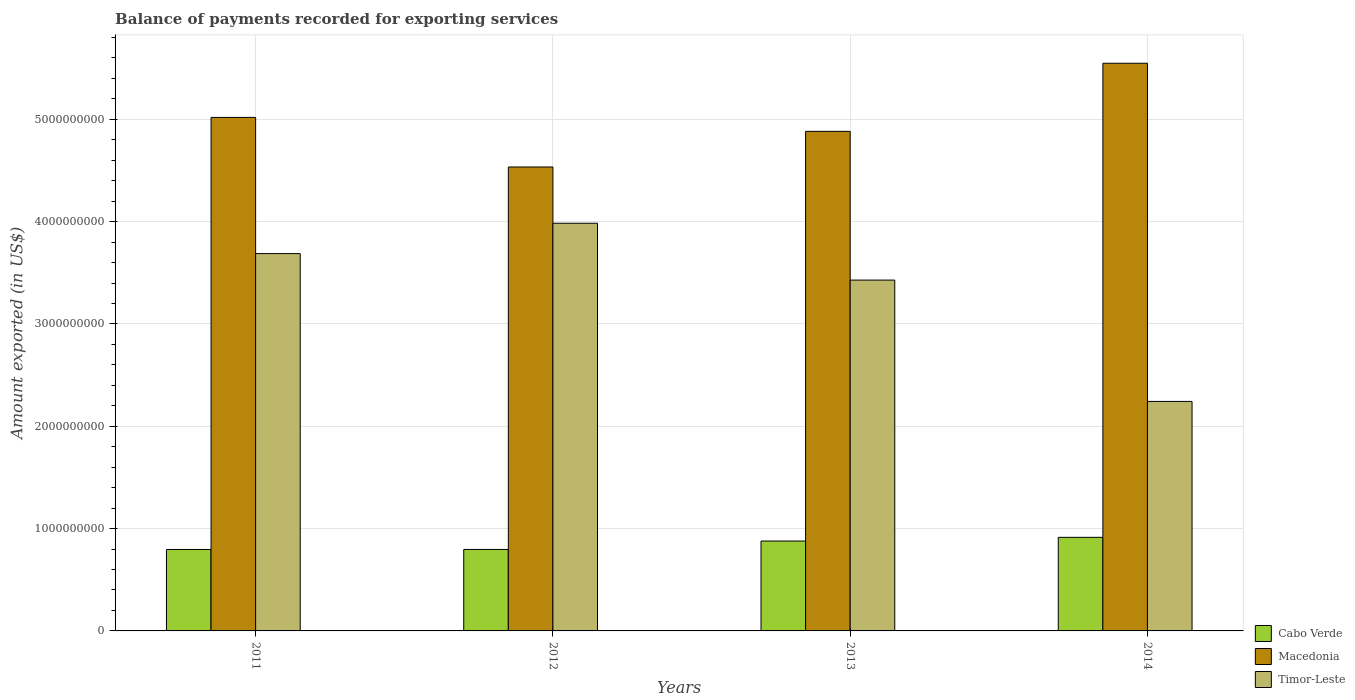How many different coloured bars are there?
Give a very brief answer. 3. How many groups of bars are there?
Offer a very short reply. 4. How many bars are there on the 3rd tick from the left?
Your answer should be very brief. 3. How many bars are there on the 3rd tick from the right?
Offer a terse response. 3. What is the amount exported in Timor-Leste in 2012?
Your answer should be very brief. 3.98e+09. Across all years, what is the maximum amount exported in Macedonia?
Your answer should be compact. 5.55e+09. Across all years, what is the minimum amount exported in Cabo Verde?
Provide a succinct answer. 7.96e+08. What is the total amount exported in Cabo Verde in the graph?
Offer a terse response. 3.39e+09. What is the difference between the amount exported in Macedonia in 2011 and that in 2012?
Your response must be concise. 4.85e+08. What is the difference between the amount exported in Cabo Verde in 2011 and the amount exported in Timor-Leste in 2012?
Provide a short and direct response. -3.19e+09. What is the average amount exported in Timor-Leste per year?
Your response must be concise. 3.34e+09. In the year 2013, what is the difference between the amount exported in Timor-Leste and amount exported in Cabo Verde?
Offer a terse response. 2.55e+09. What is the ratio of the amount exported in Cabo Verde in 2012 to that in 2013?
Make the answer very short. 0.91. What is the difference between the highest and the second highest amount exported in Macedonia?
Offer a terse response. 5.29e+08. What is the difference between the highest and the lowest amount exported in Cabo Verde?
Offer a very short reply. 1.19e+08. In how many years, is the amount exported in Timor-Leste greater than the average amount exported in Timor-Leste taken over all years?
Give a very brief answer. 3. What does the 2nd bar from the left in 2013 represents?
Your answer should be very brief. Macedonia. What does the 2nd bar from the right in 2014 represents?
Give a very brief answer. Macedonia. Is it the case that in every year, the sum of the amount exported in Macedonia and amount exported in Timor-Leste is greater than the amount exported in Cabo Verde?
Your answer should be very brief. Yes. How many bars are there?
Provide a succinct answer. 12. Does the graph contain any zero values?
Your response must be concise. No. Does the graph contain grids?
Provide a succinct answer. Yes. How are the legend labels stacked?
Keep it short and to the point. Vertical. What is the title of the graph?
Provide a short and direct response. Balance of payments recorded for exporting services. What is the label or title of the X-axis?
Keep it short and to the point. Years. What is the label or title of the Y-axis?
Offer a terse response. Amount exported (in US$). What is the Amount exported (in US$) in Cabo Verde in 2011?
Provide a short and direct response. 7.96e+08. What is the Amount exported (in US$) in Macedonia in 2011?
Provide a succinct answer. 5.02e+09. What is the Amount exported (in US$) of Timor-Leste in 2011?
Your response must be concise. 3.69e+09. What is the Amount exported (in US$) of Cabo Verde in 2012?
Your answer should be very brief. 7.96e+08. What is the Amount exported (in US$) of Macedonia in 2012?
Give a very brief answer. 4.53e+09. What is the Amount exported (in US$) in Timor-Leste in 2012?
Your answer should be very brief. 3.98e+09. What is the Amount exported (in US$) in Cabo Verde in 2013?
Give a very brief answer. 8.79e+08. What is the Amount exported (in US$) of Macedonia in 2013?
Give a very brief answer. 4.88e+09. What is the Amount exported (in US$) of Timor-Leste in 2013?
Your response must be concise. 3.43e+09. What is the Amount exported (in US$) in Cabo Verde in 2014?
Your answer should be very brief. 9.15e+08. What is the Amount exported (in US$) in Macedonia in 2014?
Your answer should be very brief. 5.55e+09. What is the Amount exported (in US$) in Timor-Leste in 2014?
Your answer should be very brief. 2.24e+09. Across all years, what is the maximum Amount exported (in US$) of Cabo Verde?
Offer a very short reply. 9.15e+08. Across all years, what is the maximum Amount exported (in US$) of Macedonia?
Ensure brevity in your answer.  5.55e+09. Across all years, what is the maximum Amount exported (in US$) of Timor-Leste?
Your response must be concise. 3.98e+09. Across all years, what is the minimum Amount exported (in US$) of Cabo Verde?
Your answer should be compact. 7.96e+08. Across all years, what is the minimum Amount exported (in US$) in Macedonia?
Offer a very short reply. 4.53e+09. Across all years, what is the minimum Amount exported (in US$) of Timor-Leste?
Give a very brief answer. 2.24e+09. What is the total Amount exported (in US$) in Cabo Verde in the graph?
Make the answer very short. 3.39e+09. What is the total Amount exported (in US$) in Macedonia in the graph?
Keep it short and to the point. 2.00e+1. What is the total Amount exported (in US$) in Timor-Leste in the graph?
Provide a succinct answer. 1.33e+1. What is the difference between the Amount exported (in US$) of Cabo Verde in 2011 and that in 2012?
Your answer should be compact. -5.88e+04. What is the difference between the Amount exported (in US$) in Macedonia in 2011 and that in 2012?
Provide a short and direct response. 4.85e+08. What is the difference between the Amount exported (in US$) in Timor-Leste in 2011 and that in 2012?
Provide a short and direct response. -2.97e+08. What is the difference between the Amount exported (in US$) in Cabo Verde in 2011 and that in 2013?
Provide a short and direct response. -8.24e+07. What is the difference between the Amount exported (in US$) in Macedonia in 2011 and that in 2013?
Keep it short and to the point. 1.36e+08. What is the difference between the Amount exported (in US$) in Timor-Leste in 2011 and that in 2013?
Offer a terse response. 2.59e+08. What is the difference between the Amount exported (in US$) of Cabo Verde in 2011 and that in 2014?
Offer a terse response. -1.19e+08. What is the difference between the Amount exported (in US$) of Macedonia in 2011 and that in 2014?
Provide a short and direct response. -5.29e+08. What is the difference between the Amount exported (in US$) of Timor-Leste in 2011 and that in 2014?
Ensure brevity in your answer.  1.44e+09. What is the difference between the Amount exported (in US$) in Cabo Verde in 2012 and that in 2013?
Make the answer very short. -8.24e+07. What is the difference between the Amount exported (in US$) in Macedonia in 2012 and that in 2013?
Provide a short and direct response. -3.48e+08. What is the difference between the Amount exported (in US$) of Timor-Leste in 2012 and that in 2013?
Ensure brevity in your answer.  5.56e+08. What is the difference between the Amount exported (in US$) in Cabo Verde in 2012 and that in 2014?
Provide a short and direct response. -1.19e+08. What is the difference between the Amount exported (in US$) in Macedonia in 2012 and that in 2014?
Give a very brief answer. -1.01e+09. What is the difference between the Amount exported (in US$) of Timor-Leste in 2012 and that in 2014?
Make the answer very short. 1.74e+09. What is the difference between the Amount exported (in US$) of Cabo Verde in 2013 and that in 2014?
Give a very brief answer. -3.62e+07. What is the difference between the Amount exported (in US$) in Macedonia in 2013 and that in 2014?
Offer a terse response. -6.66e+08. What is the difference between the Amount exported (in US$) of Timor-Leste in 2013 and that in 2014?
Provide a short and direct response. 1.19e+09. What is the difference between the Amount exported (in US$) of Cabo Verde in 2011 and the Amount exported (in US$) of Macedonia in 2012?
Your answer should be compact. -3.74e+09. What is the difference between the Amount exported (in US$) of Cabo Verde in 2011 and the Amount exported (in US$) of Timor-Leste in 2012?
Your response must be concise. -3.19e+09. What is the difference between the Amount exported (in US$) of Macedonia in 2011 and the Amount exported (in US$) of Timor-Leste in 2012?
Provide a short and direct response. 1.03e+09. What is the difference between the Amount exported (in US$) in Cabo Verde in 2011 and the Amount exported (in US$) in Macedonia in 2013?
Your answer should be compact. -4.09e+09. What is the difference between the Amount exported (in US$) in Cabo Verde in 2011 and the Amount exported (in US$) in Timor-Leste in 2013?
Your response must be concise. -2.63e+09. What is the difference between the Amount exported (in US$) of Macedonia in 2011 and the Amount exported (in US$) of Timor-Leste in 2013?
Provide a short and direct response. 1.59e+09. What is the difference between the Amount exported (in US$) of Cabo Verde in 2011 and the Amount exported (in US$) of Macedonia in 2014?
Make the answer very short. -4.75e+09. What is the difference between the Amount exported (in US$) of Cabo Verde in 2011 and the Amount exported (in US$) of Timor-Leste in 2014?
Your response must be concise. -1.45e+09. What is the difference between the Amount exported (in US$) of Macedonia in 2011 and the Amount exported (in US$) of Timor-Leste in 2014?
Offer a very short reply. 2.78e+09. What is the difference between the Amount exported (in US$) of Cabo Verde in 2012 and the Amount exported (in US$) of Macedonia in 2013?
Give a very brief answer. -4.09e+09. What is the difference between the Amount exported (in US$) in Cabo Verde in 2012 and the Amount exported (in US$) in Timor-Leste in 2013?
Offer a terse response. -2.63e+09. What is the difference between the Amount exported (in US$) of Macedonia in 2012 and the Amount exported (in US$) of Timor-Leste in 2013?
Your answer should be compact. 1.11e+09. What is the difference between the Amount exported (in US$) of Cabo Verde in 2012 and the Amount exported (in US$) of Macedonia in 2014?
Give a very brief answer. -4.75e+09. What is the difference between the Amount exported (in US$) in Cabo Verde in 2012 and the Amount exported (in US$) in Timor-Leste in 2014?
Provide a succinct answer. -1.45e+09. What is the difference between the Amount exported (in US$) of Macedonia in 2012 and the Amount exported (in US$) of Timor-Leste in 2014?
Offer a very short reply. 2.29e+09. What is the difference between the Amount exported (in US$) in Cabo Verde in 2013 and the Amount exported (in US$) in Macedonia in 2014?
Provide a succinct answer. -4.67e+09. What is the difference between the Amount exported (in US$) in Cabo Verde in 2013 and the Amount exported (in US$) in Timor-Leste in 2014?
Your answer should be compact. -1.36e+09. What is the difference between the Amount exported (in US$) of Macedonia in 2013 and the Amount exported (in US$) of Timor-Leste in 2014?
Offer a very short reply. 2.64e+09. What is the average Amount exported (in US$) of Cabo Verde per year?
Offer a very short reply. 8.46e+08. What is the average Amount exported (in US$) of Macedonia per year?
Give a very brief answer. 5.00e+09. What is the average Amount exported (in US$) in Timor-Leste per year?
Offer a terse response. 3.34e+09. In the year 2011, what is the difference between the Amount exported (in US$) of Cabo Verde and Amount exported (in US$) of Macedonia?
Offer a terse response. -4.22e+09. In the year 2011, what is the difference between the Amount exported (in US$) of Cabo Verde and Amount exported (in US$) of Timor-Leste?
Your answer should be very brief. -2.89e+09. In the year 2011, what is the difference between the Amount exported (in US$) of Macedonia and Amount exported (in US$) of Timor-Leste?
Provide a succinct answer. 1.33e+09. In the year 2012, what is the difference between the Amount exported (in US$) in Cabo Verde and Amount exported (in US$) in Macedonia?
Provide a succinct answer. -3.74e+09. In the year 2012, what is the difference between the Amount exported (in US$) of Cabo Verde and Amount exported (in US$) of Timor-Leste?
Offer a terse response. -3.19e+09. In the year 2012, what is the difference between the Amount exported (in US$) in Macedonia and Amount exported (in US$) in Timor-Leste?
Ensure brevity in your answer.  5.50e+08. In the year 2013, what is the difference between the Amount exported (in US$) of Cabo Verde and Amount exported (in US$) of Macedonia?
Make the answer very short. -4.00e+09. In the year 2013, what is the difference between the Amount exported (in US$) in Cabo Verde and Amount exported (in US$) in Timor-Leste?
Offer a terse response. -2.55e+09. In the year 2013, what is the difference between the Amount exported (in US$) in Macedonia and Amount exported (in US$) in Timor-Leste?
Make the answer very short. 1.45e+09. In the year 2014, what is the difference between the Amount exported (in US$) in Cabo Verde and Amount exported (in US$) in Macedonia?
Give a very brief answer. -4.63e+09. In the year 2014, what is the difference between the Amount exported (in US$) in Cabo Verde and Amount exported (in US$) in Timor-Leste?
Give a very brief answer. -1.33e+09. In the year 2014, what is the difference between the Amount exported (in US$) of Macedonia and Amount exported (in US$) of Timor-Leste?
Make the answer very short. 3.31e+09. What is the ratio of the Amount exported (in US$) in Cabo Verde in 2011 to that in 2012?
Ensure brevity in your answer.  1. What is the ratio of the Amount exported (in US$) of Macedonia in 2011 to that in 2012?
Give a very brief answer. 1.11. What is the ratio of the Amount exported (in US$) of Timor-Leste in 2011 to that in 2012?
Your answer should be very brief. 0.93. What is the ratio of the Amount exported (in US$) in Cabo Verde in 2011 to that in 2013?
Your answer should be compact. 0.91. What is the ratio of the Amount exported (in US$) of Macedonia in 2011 to that in 2013?
Offer a very short reply. 1.03. What is the ratio of the Amount exported (in US$) of Timor-Leste in 2011 to that in 2013?
Make the answer very short. 1.08. What is the ratio of the Amount exported (in US$) of Cabo Verde in 2011 to that in 2014?
Keep it short and to the point. 0.87. What is the ratio of the Amount exported (in US$) of Macedonia in 2011 to that in 2014?
Your response must be concise. 0.9. What is the ratio of the Amount exported (in US$) in Timor-Leste in 2011 to that in 2014?
Offer a terse response. 1.64. What is the ratio of the Amount exported (in US$) of Cabo Verde in 2012 to that in 2013?
Your response must be concise. 0.91. What is the ratio of the Amount exported (in US$) of Macedonia in 2012 to that in 2013?
Provide a succinct answer. 0.93. What is the ratio of the Amount exported (in US$) of Timor-Leste in 2012 to that in 2013?
Provide a succinct answer. 1.16. What is the ratio of the Amount exported (in US$) in Cabo Verde in 2012 to that in 2014?
Give a very brief answer. 0.87. What is the ratio of the Amount exported (in US$) of Macedonia in 2012 to that in 2014?
Give a very brief answer. 0.82. What is the ratio of the Amount exported (in US$) in Timor-Leste in 2012 to that in 2014?
Your answer should be very brief. 1.78. What is the ratio of the Amount exported (in US$) of Cabo Verde in 2013 to that in 2014?
Keep it short and to the point. 0.96. What is the ratio of the Amount exported (in US$) in Macedonia in 2013 to that in 2014?
Make the answer very short. 0.88. What is the ratio of the Amount exported (in US$) in Timor-Leste in 2013 to that in 2014?
Make the answer very short. 1.53. What is the difference between the highest and the second highest Amount exported (in US$) in Cabo Verde?
Give a very brief answer. 3.62e+07. What is the difference between the highest and the second highest Amount exported (in US$) in Macedonia?
Offer a very short reply. 5.29e+08. What is the difference between the highest and the second highest Amount exported (in US$) of Timor-Leste?
Your answer should be compact. 2.97e+08. What is the difference between the highest and the lowest Amount exported (in US$) of Cabo Verde?
Provide a succinct answer. 1.19e+08. What is the difference between the highest and the lowest Amount exported (in US$) of Macedonia?
Offer a terse response. 1.01e+09. What is the difference between the highest and the lowest Amount exported (in US$) in Timor-Leste?
Offer a very short reply. 1.74e+09. 